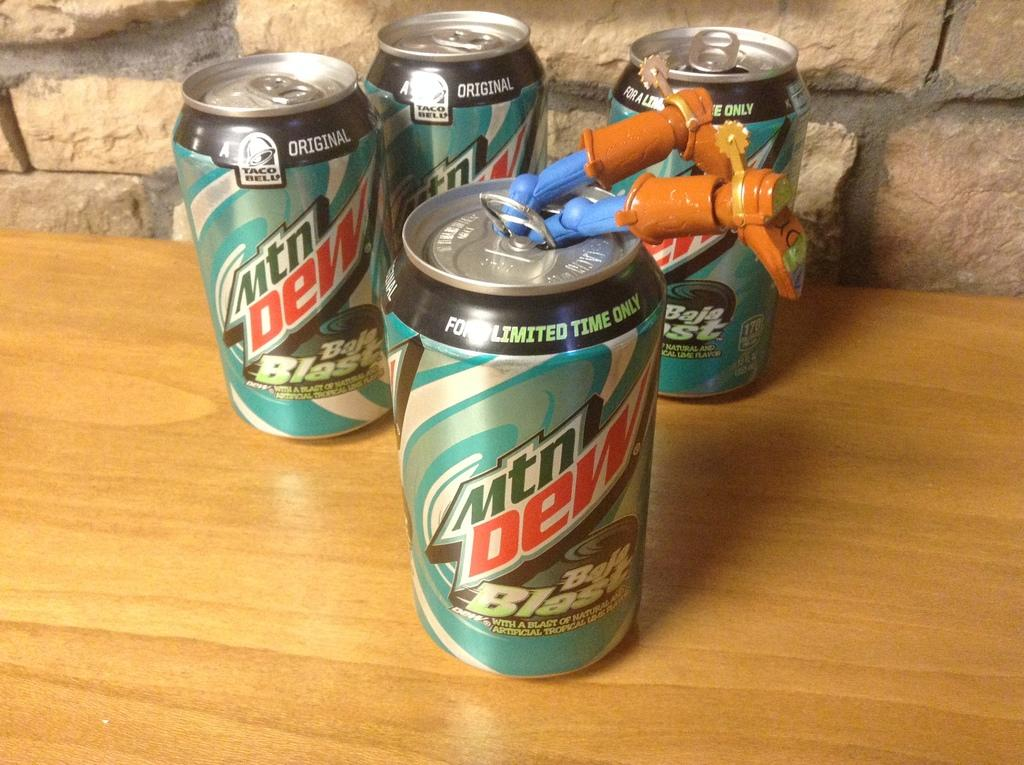<image>
Offer a succinct explanation of the picture presented. A can of Mountain Dew blast with Woody's legs sticking out of it. 